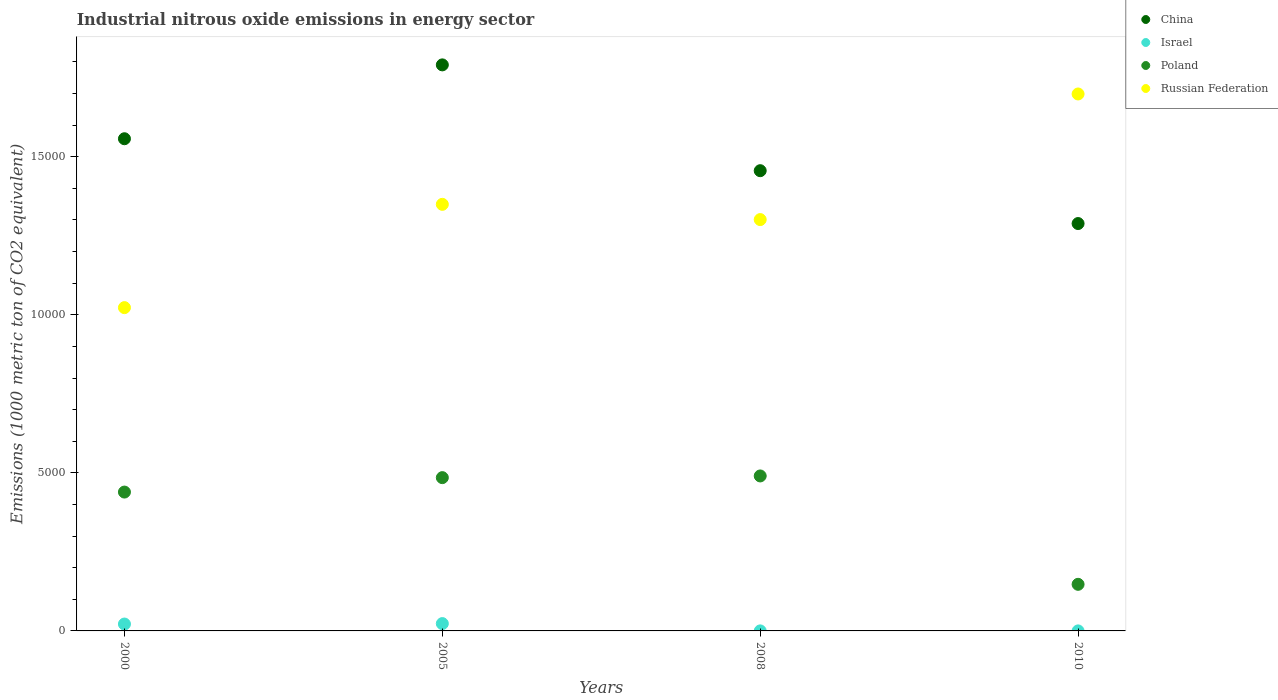Is the number of dotlines equal to the number of legend labels?
Offer a terse response. Yes. What is the amount of industrial nitrous oxide emitted in China in 2005?
Your answer should be compact. 1.79e+04. Across all years, what is the maximum amount of industrial nitrous oxide emitted in Poland?
Make the answer very short. 4902.7. Across all years, what is the minimum amount of industrial nitrous oxide emitted in Russian Federation?
Offer a terse response. 1.02e+04. What is the total amount of industrial nitrous oxide emitted in Russian Federation in the graph?
Your answer should be compact. 5.37e+04. What is the difference between the amount of industrial nitrous oxide emitted in China in 2000 and that in 2008?
Provide a succinct answer. 1010.8. What is the difference between the amount of industrial nitrous oxide emitted in China in 2000 and the amount of industrial nitrous oxide emitted in Russian Federation in 2008?
Offer a very short reply. 2557.4. What is the average amount of industrial nitrous oxide emitted in Russian Federation per year?
Offer a very short reply. 1.34e+04. In the year 2010, what is the difference between the amount of industrial nitrous oxide emitted in China and amount of industrial nitrous oxide emitted in Russian Federation?
Give a very brief answer. -4098.7. In how many years, is the amount of industrial nitrous oxide emitted in Israel greater than 1000 1000 metric ton?
Keep it short and to the point. 0. What is the ratio of the amount of industrial nitrous oxide emitted in Russian Federation in 2000 to that in 2008?
Ensure brevity in your answer.  0.79. What is the difference between the highest and the second highest amount of industrial nitrous oxide emitted in Poland?
Keep it short and to the point. 53.7. What is the difference between the highest and the lowest amount of industrial nitrous oxide emitted in Israel?
Your answer should be very brief. 231. In how many years, is the amount of industrial nitrous oxide emitted in Israel greater than the average amount of industrial nitrous oxide emitted in Israel taken over all years?
Provide a short and direct response. 2. Does the amount of industrial nitrous oxide emitted in Russian Federation monotonically increase over the years?
Ensure brevity in your answer.  No. Is the amount of industrial nitrous oxide emitted in Israel strictly greater than the amount of industrial nitrous oxide emitted in Poland over the years?
Your answer should be very brief. No. Is the amount of industrial nitrous oxide emitted in Russian Federation strictly less than the amount of industrial nitrous oxide emitted in China over the years?
Offer a very short reply. No. How many dotlines are there?
Offer a very short reply. 4. Are the values on the major ticks of Y-axis written in scientific E-notation?
Offer a terse response. No. Does the graph contain grids?
Provide a short and direct response. No. Where does the legend appear in the graph?
Your answer should be compact. Top right. How many legend labels are there?
Keep it short and to the point. 4. What is the title of the graph?
Your response must be concise. Industrial nitrous oxide emissions in energy sector. What is the label or title of the Y-axis?
Make the answer very short. Emissions (1000 metric ton of CO2 equivalent). What is the Emissions (1000 metric ton of CO2 equivalent) in China in 2000?
Provide a succinct answer. 1.56e+04. What is the Emissions (1000 metric ton of CO2 equivalent) of Israel in 2000?
Provide a succinct answer. 217.6. What is the Emissions (1000 metric ton of CO2 equivalent) in Poland in 2000?
Provide a short and direct response. 4392.5. What is the Emissions (1000 metric ton of CO2 equivalent) in Russian Federation in 2000?
Keep it short and to the point. 1.02e+04. What is the Emissions (1000 metric ton of CO2 equivalent) in China in 2005?
Your answer should be very brief. 1.79e+04. What is the Emissions (1000 metric ton of CO2 equivalent) in Israel in 2005?
Offer a very short reply. 231.6. What is the Emissions (1000 metric ton of CO2 equivalent) of Poland in 2005?
Make the answer very short. 4849. What is the Emissions (1000 metric ton of CO2 equivalent) of Russian Federation in 2005?
Your response must be concise. 1.35e+04. What is the Emissions (1000 metric ton of CO2 equivalent) in China in 2008?
Provide a short and direct response. 1.46e+04. What is the Emissions (1000 metric ton of CO2 equivalent) in Poland in 2008?
Provide a short and direct response. 4902.7. What is the Emissions (1000 metric ton of CO2 equivalent) in Russian Federation in 2008?
Keep it short and to the point. 1.30e+04. What is the Emissions (1000 metric ton of CO2 equivalent) in China in 2010?
Keep it short and to the point. 1.29e+04. What is the Emissions (1000 metric ton of CO2 equivalent) of Poland in 2010?
Provide a short and direct response. 1474.1. What is the Emissions (1000 metric ton of CO2 equivalent) in Russian Federation in 2010?
Your answer should be very brief. 1.70e+04. Across all years, what is the maximum Emissions (1000 metric ton of CO2 equivalent) of China?
Give a very brief answer. 1.79e+04. Across all years, what is the maximum Emissions (1000 metric ton of CO2 equivalent) in Israel?
Make the answer very short. 231.6. Across all years, what is the maximum Emissions (1000 metric ton of CO2 equivalent) in Poland?
Your answer should be very brief. 4902.7. Across all years, what is the maximum Emissions (1000 metric ton of CO2 equivalent) of Russian Federation?
Ensure brevity in your answer.  1.70e+04. Across all years, what is the minimum Emissions (1000 metric ton of CO2 equivalent) in China?
Give a very brief answer. 1.29e+04. Across all years, what is the minimum Emissions (1000 metric ton of CO2 equivalent) in Israel?
Make the answer very short. 0.6. Across all years, what is the minimum Emissions (1000 metric ton of CO2 equivalent) of Poland?
Make the answer very short. 1474.1. Across all years, what is the minimum Emissions (1000 metric ton of CO2 equivalent) in Russian Federation?
Your answer should be compact. 1.02e+04. What is the total Emissions (1000 metric ton of CO2 equivalent) of China in the graph?
Offer a terse response. 6.09e+04. What is the total Emissions (1000 metric ton of CO2 equivalent) in Israel in the graph?
Offer a very short reply. 450.8. What is the total Emissions (1000 metric ton of CO2 equivalent) of Poland in the graph?
Your answer should be compact. 1.56e+04. What is the total Emissions (1000 metric ton of CO2 equivalent) of Russian Federation in the graph?
Make the answer very short. 5.37e+04. What is the difference between the Emissions (1000 metric ton of CO2 equivalent) in China in 2000 and that in 2005?
Provide a short and direct response. -2336.7. What is the difference between the Emissions (1000 metric ton of CO2 equivalent) in Poland in 2000 and that in 2005?
Provide a short and direct response. -456.5. What is the difference between the Emissions (1000 metric ton of CO2 equivalent) in Russian Federation in 2000 and that in 2005?
Ensure brevity in your answer.  -3267.5. What is the difference between the Emissions (1000 metric ton of CO2 equivalent) of China in 2000 and that in 2008?
Provide a succinct answer. 1010.8. What is the difference between the Emissions (1000 metric ton of CO2 equivalent) of Israel in 2000 and that in 2008?
Your response must be concise. 216.6. What is the difference between the Emissions (1000 metric ton of CO2 equivalent) in Poland in 2000 and that in 2008?
Ensure brevity in your answer.  -510.2. What is the difference between the Emissions (1000 metric ton of CO2 equivalent) of Russian Federation in 2000 and that in 2008?
Provide a short and direct response. -2785.2. What is the difference between the Emissions (1000 metric ton of CO2 equivalent) of China in 2000 and that in 2010?
Offer a very short reply. 2682.7. What is the difference between the Emissions (1000 metric ton of CO2 equivalent) of Israel in 2000 and that in 2010?
Provide a succinct answer. 217. What is the difference between the Emissions (1000 metric ton of CO2 equivalent) of Poland in 2000 and that in 2010?
Offer a very short reply. 2918.4. What is the difference between the Emissions (1000 metric ton of CO2 equivalent) of Russian Federation in 2000 and that in 2010?
Offer a very short reply. -6758.6. What is the difference between the Emissions (1000 metric ton of CO2 equivalent) of China in 2005 and that in 2008?
Your answer should be compact. 3347.5. What is the difference between the Emissions (1000 metric ton of CO2 equivalent) in Israel in 2005 and that in 2008?
Offer a very short reply. 230.6. What is the difference between the Emissions (1000 metric ton of CO2 equivalent) in Poland in 2005 and that in 2008?
Offer a terse response. -53.7. What is the difference between the Emissions (1000 metric ton of CO2 equivalent) of Russian Federation in 2005 and that in 2008?
Provide a short and direct response. 482.3. What is the difference between the Emissions (1000 metric ton of CO2 equivalent) in China in 2005 and that in 2010?
Provide a succinct answer. 5019.4. What is the difference between the Emissions (1000 metric ton of CO2 equivalent) in Israel in 2005 and that in 2010?
Provide a short and direct response. 231. What is the difference between the Emissions (1000 metric ton of CO2 equivalent) in Poland in 2005 and that in 2010?
Provide a succinct answer. 3374.9. What is the difference between the Emissions (1000 metric ton of CO2 equivalent) of Russian Federation in 2005 and that in 2010?
Your response must be concise. -3491.1. What is the difference between the Emissions (1000 metric ton of CO2 equivalent) of China in 2008 and that in 2010?
Provide a succinct answer. 1671.9. What is the difference between the Emissions (1000 metric ton of CO2 equivalent) of Israel in 2008 and that in 2010?
Ensure brevity in your answer.  0.4. What is the difference between the Emissions (1000 metric ton of CO2 equivalent) in Poland in 2008 and that in 2010?
Provide a short and direct response. 3428.6. What is the difference between the Emissions (1000 metric ton of CO2 equivalent) in Russian Federation in 2008 and that in 2010?
Ensure brevity in your answer.  -3973.4. What is the difference between the Emissions (1000 metric ton of CO2 equivalent) in China in 2000 and the Emissions (1000 metric ton of CO2 equivalent) in Israel in 2005?
Give a very brief answer. 1.53e+04. What is the difference between the Emissions (1000 metric ton of CO2 equivalent) in China in 2000 and the Emissions (1000 metric ton of CO2 equivalent) in Poland in 2005?
Your answer should be very brief. 1.07e+04. What is the difference between the Emissions (1000 metric ton of CO2 equivalent) of China in 2000 and the Emissions (1000 metric ton of CO2 equivalent) of Russian Federation in 2005?
Give a very brief answer. 2075.1. What is the difference between the Emissions (1000 metric ton of CO2 equivalent) in Israel in 2000 and the Emissions (1000 metric ton of CO2 equivalent) in Poland in 2005?
Give a very brief answer. -4631.4. What is the difference between the Emissions (1000 metric ton of CO2 equivalent) in Israel in 2000 and the Emissions (1000 metric ton of CO2 equivalent) in Russian Federation in 2005?
Make the answer very short. -1.33e+04. What is the difference between the Emissions (1000 metric ton of CO2 equivalent) of Poland in 2000 and the Emissions (1000 metric ton of CO2 equivalent) of Russian Federation in 2005?
Your answer should be very brief. -9102.1. What is the difference between the Emissions (1000 metric ton of CO2 equivalent) of China in 2000 and the Emissions (1000 metric ton of CO2 equivalent) of Israel in 2008?
Make the answer very short. 1.56e+04. What is the difference between the Emissions (1000 metric ton of CO2 equivalent) in China in 2000 and the Emissions (1000 metric ton of CO2 equivalent) in Poland in 2008?
Provide a short and direct response. 1.07e+04. What is the difference between the Emissions (1000 metric ton of CO2 equivalent) of China in 2000 and the Emissions (1000 metric ton of CO2 equivalent) of Russian Federation in 2008?
Provide a succinct answer. 2557.4. What is the difference between the Emissions (1000 metric ton of CO2 equivalent) of Israel in 2000 and the Emissions (1000 metric ton of CO2 equivalent) of Poland in 2008?
Keep it short and to the point. -4685.1. What is the difference between the Emissions (1000 metric ton of CO2 equivalent) of Israel in 2000 and the Emissions (1000 metric ton of CO2 equivalent) of Russian Federation in 2008?
Your answer should be very brief. -1.28e+04. What is the difference between the Emissions (1000 metric ton of CO2 equivalent) in Poland in 2000 and the Emissions (1000 metric ton of CO2 equivalent) in Russian Federation in 2008?
Keep it short and to the point. -8619.8. What is the difference between the Emissions (1000 metric ton of CO2 equivalent) in China in 2000 and the Emissions (1000 metric ton of CO2 equivalent) in Israel in 2010?
Make the answer very short. 1.56e+04. What is the difference between the Emissions (1000 metric ton of CO2 equivalent) of China in 2000 and the Emissions (1000 metric ton of CO2 equivalent) of Poland in 2010?
Your answer should be very brief. 1.41e+04. What is the difference between the Emissions (1000 metric ton of CO2 equivalent) in China in 2000 and the Emissions (1000 metric ton of CO2 equivalent) in Russian Federation in 2010?
Make the answer very short. -1416. What is the difference between the Emissions (1000 metric ton of CO2 equivalent) in Israel in 2000 and the Emissions (1000 metric ton of CO2 equivalent) in Poland in 2010?
Your answer should be compact. -1256.5. What is the difference between the Emissions (1000 metric ton of CO2 equivalent) of Israel in 2000 and the Emissions (1000 metric ton of CO2 equivalent) of Russian Federation in 2010?
Keep it short and to the point. -1.68e+04. What is the difference between the Emissions (1000 metric ton of CO2 equivalent) of Poland in 2000 and the Emissions (1000 metric ton of CO2 equivalent) of Russian Federation in 2010?
Keep it short and to the point. -1.26e+04. What is the difference between the Emissions (1000 metric ton of CO2 equivalent) in China in 2005 and the Emissions (1000 metric ton of CO2 equivalent) in Israel in 2008?
Your response must be concise. 1.79e+04. What is the difference between the Emissions (1000 metric ton of CO2 equivalent) in China in 2005 and the Emissions (1000 metric ton of CO2 equivalent) in Poland in 2008?
Your answer should be compact. 1.30e+04. What is the difference between the Emissions (1000 metric ton of CO2 equivalent) in China in 2005 and the Emissions (1000 metric ton of CO2 equivalent) in Russian Federation in 2008?
Offer a terse response. 4894.1. What is the difference between the Emissions (1000 metric ton of CO2 equivalent) of Israel in 2005 and the Emissions (1000 metric ton of CO2 equivalent) of Poland in 2008?
Give a very brief answer. -4671.1. What is the difference between the Emissions (1000 metric ton of CO2 equivalent) of Israel in 2005 and the Emissions (1000 metric ton of CO2 equivalent) of Russian Federation in 2008?
Offer a terse response. -1.28e+04. What is the difference between the Emissions (1000 metric ton of CO2 equivalent) of Poland in 2005 and the Emissions (1000 metric ton of CO2 equivalent) of Russian Federation in 2008?
Offer a very short reply. -8163.3. What is the difference between the Emissions (1000 metric ton of CO2 equivalent) of China in 2005 and the Emissions (1000 metric ton of CO2 equivalent) of Israel in 2010?
Keep it short and to the point. 1.79e+04. What is the difference between the Emissions (1000 metric ton of CO2 equivalent) in China in 2005 and the Emissions (1000 metric ton of CO2 equivalent) in Poland in 2010?
Give a very brief answer. 1.64e+04. What is the difference between the Emissions (1000 metric ton of CO2 equivalent) of China in 2005 and the Emissions (1000 metric ton of CO2 equivalent) of Russian Federation in 2010?
Your answer should be compact. 920.7. What is the difference between the Emissions (1000 metric ton of CO2 equivalent) of Israel in 2005 and the Emissions (1000 metric ton of CO2 equivalent) of Poland in 2010?
Ensure brevity in your answer.  -1242.5. What is the difference between the Emissions (1000 metric ton of CO2 equivalent) of Israel in 2005 and the Emissions (1000 metric ton of CO2 equivalent) of Russian Federation in 2010?
Your answer should be compact. -1.68e+04. What is the difference between the Emissions (1000 metric ton of CO2 equivalent) in Poland in 2005 and the Emissions (1000 metric ton of CO2 equivalent) in Russian Federation in 2010?
Keep it short and to the point. -1.21e+04. What is the difference between the Emissions (1000 metric ton of CO2 equivalent) of China in 2008 and the Emissions (1000 metric ton of CO2 equivalent) of Israel in 2010?
Make the answer very short. 1.46e+04. What is the difference between the Emissions (1000 metric ton of CO2 equivalent) in China in 2008 and the Emissions (1000 metric ton of CO2 equivalent) in Poland in 2010?
Provide a short and direct response. 1.31e+04. What is the difference between the Emissions (1000 metric ton of CO2 equivalent) of China in 2008 and the Emissions (1000 metric ton of CO2 equivalent) of Russian Federation in 2010?
Your answer should be compact. -2426.8. What is the difference between the Emissions (1000 metric ton of CO2 equivalent) of Israel in 2008 and the Emissions (1000 metric ton of CO2 equivalent) of Poland in 2010?
Ensure brevity in your answer.  -1473.1. What is the difference between the Emissions (1000 metric ton of CO2 equivalent) of Israel in 2008 and the Emissions (1000 metric ton of CO2 equivalent) of Russian Federation in 2010?
Your answer should be compact. -1.70e+04. What is the difference between the Emissions (1000 metric ton of CO2 equivalent) of Poland in 2008 and the Emissions (1000 metric ton of CO2 equivalent) of Russian Federation in 2010?
Your response must be concise. -1.21e+04. What is the average Emissions (1000 metric ton of CO2 equivalent) in China per year?
Provide a succinct answer. 1.52e+04. What is the average Emissions (1000 metric ton of CO2 equivalent) of Israel per year?
Provide a succinct answer. 112.7. What is the average Emissions (1000 metric ton of CO2 equivalent) of Poland per year?
Give a very brief answer. 3904.57. What is the average Emissions (1000 metric ton of CO2 equivalent) of Russian Federation per year?
Offer a terse response. 1.34e+04. In the year 2000, what is the difference between the Emissions (1000 metric ton of CO2 equivalent) of China and Emissions (1000 metric ton of CO2 equivalent) of Israel?
Ensure brevity in your answer.  1.54e+04. In the year 2000, what is the difference between the Emissions (1000 metric ton of CO2 equivalent) in China and Emissions (1000 metric ton of CO2 equivalent) in Poland?
Make the answer very short. 1.12e+04. In the year 2000, what is the difference between the Emissions (1000 metric ton of CO2 equivalent) in China and Emissions (1000 metric ton of CO2 equivalent) in Russian Federation?
Your answer should be very brief. 5342.6. In the year 2000, what is the difference between the Emissions (1000 metric ton of CO2 equivalent) in Israel and Emissions (1000 metric ton of CO2 equivalent) in Poland?
Your response must be concise. -4174.9. In the year 2000, what is the difference between the Emissions (1000 metric ton of CO2 equivalent) of Israel and Emissions (1000 metric ton of CO2 equivalent) of Russian Federation?
Provide a succinct answer. -1.00e+04. In the year 2000, what is the difference between the Emissions (1000 metric ton of CO2 equivalent) of Poland and Emissions (1000 metric ton of CO2 equivalent) of Russian Federation?
Ensure brevity in your answer.  -5834.6. In the year 2005, what is the difference between the Emissions (1000 metric ton of CO2 equivalent) of China and Emissions (1000 metric ton of CO2 equivalent) of Israel?
Your answer should be very brief. 1.77e+04. In the year 2005, what is the difference between the Emissions (1000 metric ton of CO2 equivalent) in China and Emissions (1000 metric ton of CO2 equivalent) in Poland?
Provide a short and direct response. 1.31e+04. In the year 2005, what is the difference between the Emissions (1000 metric ton of CO2 equivalent) in China and Emissions (1000 metric ton of CO2 equivalent) in Russian Federation?
Your response must be concise. 4411.8. In the year 2005, what is the difference between the Emissions (1000 metric ton of CO2 equivalent) in Israel and Emissions (1000 metric ton of CO2 equivalent) in Poland?
Your response must be concise. -4617.4. In the year 2005, what is the difference between the Emissions (1000 metric ton of CO2 equivalent) of Israel and Emissions (1000 metric ton of CO2 equivalent) of Russian Federation?
Offer a very short reply. -1.33e+04. In the year 2005, what is the difference between the Emissions (1000 metric ton of CO2 equivalent) in Poland and Emissions (1000 metric ton of CO2 equivalent) in Russian Federation?
Provide a succinct answer. -8645.6. In the year 2008, what is the difference between the Emissions (1000 metric ton of CO2 equivalent) in China and Emissions (1000 metric ton of CO2 equivalent) in Israel?
Give a very brief answer. 1.46e+04. In the year 2008, what is the difference between the Emissions (1000 metric ton of CO2 equivalent) of China and Emissions (1000 metric ton of CO2 equivalent) of Poland?
Keep it short and to the point. 9656.2. In the year 2008, what is the difference between the Emissions (1000 metric ton of CO2 equivalent) in China and Emissions (1000 metric ton of CO2 equivalent) in Russian Federation?
Your answer should be very brief. 1546.6. In the year 2008, what is the difference between the Emissions (1000 metric ton of CO2 equivalent) in Israel and Emissions (1000 metric ton of CO2 equivalent) in Poland?
Your answer should be compact. -4901.7. In the year 2008, what is the difference between the Emissions (1000 metric ton of CO2 equivalent) of Israel and Emissions (1000 metric ton of CO2 equivalent) of Russian Federation?
Offer a terse response. -1.30e+04. In the year 2008, what is the difference between the Emissions (1000 metric ton of CO2 equivalent) of Poland and Emissions (1000 metric ton of CO2 equivalent) of Russian Federation?
Your answer should be very brief. -8109.6. In the year 2010, what is the difference between the Emissions (1000 metric ton of CO2 equivalent) in China and Emissions (1000 metric ton of CO2 equivalent) in Israel?
Your response must be concise. 1.29e+04. In the year 2010, what is the difference between the Emissions (1000 metric ton of CO2 equivalent) in China and Emissions (1000 metric ton of CO2 equivalent) in Poland?
Offer a very short reply. 1.14e+04. In the year 2010, what is the difference between the Emissions (1000 metric ton of CO2 equivalent) in China and Emissions (1000 metric ton of CO2 equivalent) in Russian Federation?
Give a very brief answer. -4098.7. In the year 2010, what is the difference between the Emissions (1000 metric ton of CO2 equivalent) of Israel and Emissions (1000 metric ton of CO2 equivalent) of Poland?
Give a very brief answer. -1473.5. In the year 2010, what is the difference between the Emissions (1000 metric ton of CO2 equivalent) in Israel and Emissions (1000 metric ton of CO2 equivalent) in Russian Federation?
Your answer should be compact. -1.70e+04. In the year 2010, what is the difference between the Emissions (1000 metric ton of CO2 equivalent) of Poland and Emissions (1000 metric ton of CO2 equivalent) of Russian Federation?
Your answer should be very brief. -1.55e+04. What is the ratio of the Emissions (1000 metric ton of CO2 equivalent) of China in 2000 to that in 2005?
Your response must be concise. 0.87. What is the ratio of the Emissions (1000 metric ton of CO2 equivalent) of Israel in 2000 to that in 2005?
Keep it short and to the point. 0.94. What is the ratio of the Emissions (1000 metric ton of CO2 equivalent) of Poland in 2000 to that in 2005?
Your response must be concise. 0.91. What is the ratio of the Emissions (1000 metric ton of CO2 equivalent) of Russian Federation in 2000 to that in 2005?
Make the answer very short. 0.76. What is the ratio of the Emissions (1000 metric ton of CO2 equivalent) in China in 2000 to that in 2008?
Your answer should be compact. 1.07. What is the ratio of the Emissions (1000 metric ton of CO2 equivalent) in Israel in 2000 to that in 2008?
Provide a succinct answer. 217.6. What is the ratio of the Emissions (1000 metric ton of CO2 equivalent) of Poland in 2000 to that in 2008?
Make the answer very short. 0.9. What is the ratio of the Emissions (1000 metric ton of CO2 equivalent) of Russian Federation in 2000 to that in 2008?
Your response must be concise. 0.79. What is the ratio of the Emissions (1000 metric ton of CO2 equivalent) in China in 2000 to that in 2010?
Ensure brevity in your answer.  1.21. What is the ratio of the Emissions (1000 metric ton of CO2 equivalent) of Israel in 2000 to that in 2010?
Ensure brevity in your answer.  362.67. What is the ratio of the Emissions (1000 metric ton of CO2 equivalent) in Poland in 2000 to that in 2010?
Offer a very short reply. 2.98. What is the ratio of the Emissions (1000 metric ton of CO2 equivalent) of Russian Federation in 2000 to that in 2010?
Your answer should be very brief. 0.6. What is the ratio of the Emissions (1000 metric ton of CO2 equivalent) of China in 2005 to that in 2008?
Ensure brevity in your answer.  1.23. What is the ratio of the Emissions (1000 metric ton of CO2 equivalent) of Israel in 2005 to that in 2008?
Your answer should be compact. 231.6. What is the ratio of the Emissions (1000 metric ton of CO2 equivalent) of Russian Federation in 2005 to that in 2008?
Your answer should be compact. 1.04. What is the ratio of the Emissions (1000 metric ton of CO2 equivalent) of China in 2005 to that in 2010?
Make the answer very short. 1.39. What is the ratio of the Emissions (1000 metric ton of CO2 equivalent) of Israel in 2005 to that in 2010?
Your response must be concise. 386. What is the ratio of the Emissions (1000 metric ton of CO2 equivalent) in Poland in 2005 to that in 2010?
Your answer should be compact. 3.29. What is the ratio of the Emissions (1000 metric ton of CO2 equivalent) in Russian Federation in 2005 to that in 2010?
Provide a succinct answer. 0.79. What is the ratio of the Emissions (1000 metric ton of CO2 equivalent) of China in 2008 to that in 2010?
Your response must be concise. 1.13. What is the ratio of the Emissions (1000 metric ton of CO2 equivalent) of Poland in 2008 to that in 2010?
Offer a very short reply. 3.33. What is the ratio of the Emissions (1000 metric ton of CO2 equivalent) in Russian Federation in 2008 to that in 2010?
Your response must be concise. 0.77. What is the difference between the highest and the second highest Emissions (1000 metric ton of CO2 equivalent) in China?
Your answer should be compact. 2336.7. What is the difference between the highest and the second highest Emissions (1000 metric ton of CO2 equivalent) in Israel?
Provide a short and direct response. 14. What is the difference between the highest and the second highest Emissions (1000 metric ton of CO2 equivalent) in Poland?
Provide a succinct answer. 53.7. What is the difference between the highest and the second highest Emissions (1000 metric ton of CO2 equivalent) of Russian Federation?
Offer a very short reply. 3491.1. What is the difference between the highest and the lowest Emissions (1000 metric ton of CO2 equivalent) of China?
Your response must be concise. 5019.4. What is the difference between the highest and the lowest Emissions (1000 metric ton of CO2 equivalent) of Israel?
Give a very brief answer. 231. What is the difference between the highest and the lowest Emissions (1000 metric ton of CO2 equivalent) of Poland?
Your response must be concise. 3428.6. What is the difference between the highest and the lowest Emissions (1000 metric ton of CO2 equivalent) of Russian Federation?
Ensure brevity in your answer.  6758.6. 